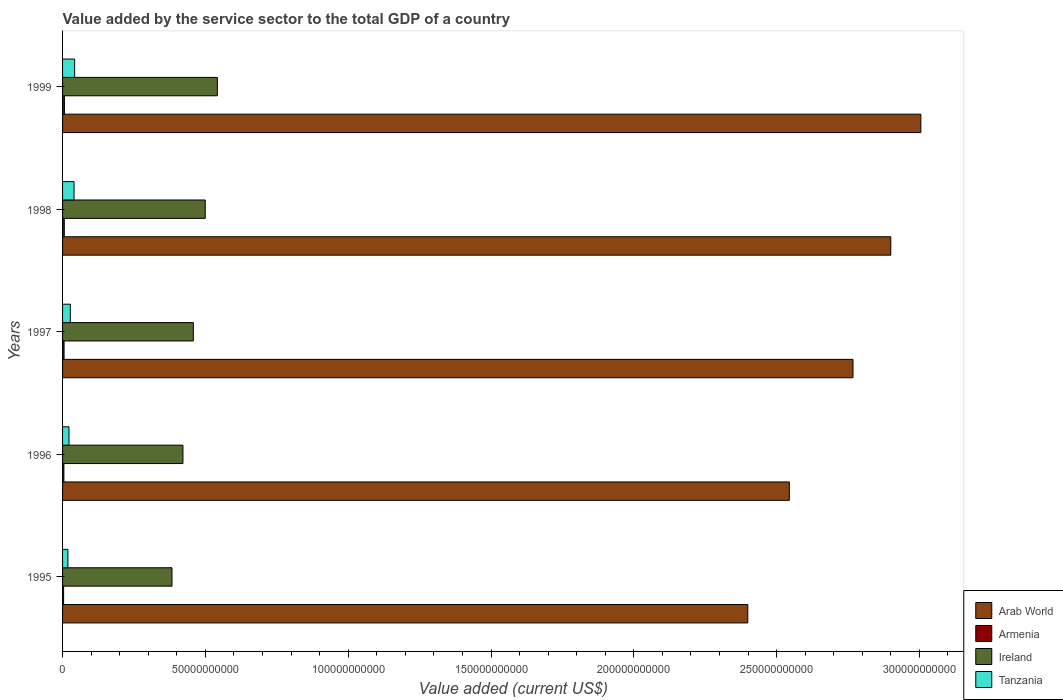Are the number of bars per tick equal to the number of legend labels?
Offer a very short reply. Yes. In how many cases, is the number of bars for a given year not equal to the number of legend labels?
Ensure brevity in your answer.  0. What is the value added by the service sector to the total GDP in Ireland in 1998?
Your answer should be very brief. 5.00e+1. Across all years, what is the maximum value added by the service sector to the total GDP in Ireland?
Make the answer very short. 5.42e+1. Across all years, what is the minimum value added by the service sector to the total GDP in Tanzania?
Your answer should be very brief. 1.87e+09. What is the total value added by the service sector to the total GDP in Ireland in the graph?
Give a very brief answer. 2.30e+11. What is the difference between the value added by the service sector to the total GDP in Tanzania in 1995 and that in 1996?
Offer a terse response. -3.81e+08. What is the difference between the value added by the service sector to the total GDP in Ireland in 1996 and the value added by the service sector to the total GDP in Arab World in 1995?
Provide a short and direct response. -1.98e+11. What is the average value added by the service sector to the total GDP in Armenia per year?
Give a very brief answer. 5.21e+08. In the year 1997, what is the difference between the value added by the service sector to the total GDP in Tanzania and value added by the service sector to the total GDP in Ireland?
Keep it short and to the point. -4.31e+1. In how many years, is the value added by the service sector to the total GDP in Ireland greater than 80000000000 US$?
Provide a short and direct response. 0. What is the ratio of the value added by the service sector to the total GDP in Ireland in 1996 to that in 1998?
Your response must be concise. 0.84. What is the difference between the highest and the second highest value added by the service sector to the total GDP in Ireland?
Give a very brief answer. 4.24e+09. What is the difference between the highest and the lowest value added by the service sector to the total GDP in Armenia?
Keep it short and to the point. 2.83e+08. In how many years, is the value added by the service sector to the total GDP in Arab World greater than the average value added by the service sector to the total GDP in Arab World taken over all years?
Your answer should be compact. 3. Is the sum of the value added by the service sector to the total GDP in Arab World in 1996 and 1998 greater than the maximum value added by the service sector to the total GDP in Armenia across all years?
Provide a short and direct response. Yes. Is it the case that in every year, the sum of the value added by the service sector to the total GDP in Arab World and value added by the service sector to the total GDP in Ireland is greater than the sum of value added by the service sector to the total GDP in Armenia and value added by the service sector to the total GDP in Tanzania?
Your response must be concise. Yes. What does the 3rd bar from the top in 1997 represents?
Provide a succinct answer. Armenia. What does the 2nd bar from the bottom in 1999 represents?
Offer a terse response. Armenia. How many bars are there?
Keep it short and to the point. 20. How many years are there in the graph?
Provide a short and direct response. 5. How are the legend labels stacked?
Make the answer very short. Vertical. What is the title of the graph?
Provide a succinct answer. Value added by the service sector to the total GDP of a country. Does "Ethiopia" appear as one of the legend labels in the graph?
Offer a very short reply. No. What is the label or title of the X-axis?
Ensure brevity in your answer.  Value added (current US$). What is the Value added (current US$) in Arab World in 1995?
Keep it short and to the point. 2.40e+11. What is the Value added (current US$) of Armenia in 1995?
Give a very brief answer. 3.64e+08. What is the Value added (current US$) in Ireland in 1995?
Keep it short and to the point. 3.83e+1. What is the Value added (current US$) of Tanzania in 1995?
Offer a terse response. 1.87e+09. What is the Value added (current US$) in Arab World in 1996?
Your answer should be very brief. 2.54e+11. What is the Value added (current US$) in Armenia in 1996?
Offer a terse response. 4.62e+08. What is the Value added (current US$) of Ireland in 1996?
Ensure brevity in your answer.  4.21e+1. What is the Value added (current US$) of Tanzania in 1996?
Your answer should be very brief. 2.25e+09. What is the Value added (current US$) in Arab World in 1997?
Offer a very short reply. 2.77e+11. What is the Value added (current US$) of Armenia in 1997?
Your response must be concise. 5.25e+08. What is the Value added (current US$) of Ireland in 1997?
Your response must be concise. 4.58e+1. What is the Value added (current US$) in Tanzania in 1997?
Ensure brevity in your answer.  2.72e+09. What is the Value added (current US$) in Arab World in 1998?
Provide a short and direct response. 2.90e+11. What is the Value added (current US$) of Armenia in 1998?
Your answer should be very brief. 6.06e+08. What is the Value added (current US$) of Ireland in 1998?
Your answer should be compact. 5.00e+1. What is the Value added (current US$) in Tanzania in 1998?
Ensure brevity in your answer.  4.02e+09. What is the Value added (current US$) of Arab World in 1999?
Your response must be concise. 3.00e+11. What is the Value added (current US$) in Armenia in 1999?
Make the answer very short. 6.47e+08. What is the Value added (current US$) in Ireland in 1999?
Make the answer very short. 5.42e+1. What is the Value added (current US$) in Tanzania in 1999?
Your response must be concise. 4.23e+09. Across all years, what is the maximum Value added (current US$) of Arab World?
Offer a very short reply. 3.00e+11. Across all years, what is the maximum Value added (current US$) of Armenia?
Offer a terse response. 6.47e+08. Across all years, what is the maximum Value added (current US$) of Ireland?
Your response must be concise. 5.42e+1. Across all years, what is the maximum Value added (current US$) in Tanzania?
Ensure brevity in your answer.  4.23e+09. Across all years, what is the minimum Value added (current US$) of Arab World?
Keep it short and to the point. 2.40e+11. Across all years, what is the minimum Value added (current US$) of Armenia?
Ensure brevity in your answer.  3.64e+08. Across all years, what is the minimum Value added (current US$) of Ireland?
Provide a short and direct response. 3.83e+1. Across all years, what is the minimum Value added (current US$) of Tanzania?
Give a very brief answer. 1.87e+09. What is the total Value added (current US$) of Arab World in the graph?
Your response must be concise. 1.36e+12. What is the total Value added (current US$) in Armenia in the graph?
Provide a short and direct response. 2.60e+09. What is the total Value added (current US$) of Ireland in the graph?
Provide a short and direct response. 2.30e+11. What is the total Value added (current US$) of Tanzania in the graph?
Your response must be concise. 1.51e+1. What is the difference between the Value added (current US$) of Arab World in 1995 and that in 1996?
Ensure brevity in your answer.  -1.46e+1. What is the difference between the Value added (current US$) of Armenia in 1995 and that in 1996?
Make the answer very short. -9.73e+07. What is the difference between the Value added (current US$) of Ireland in 1995 and that in 1996?
Offer a terse response. -3.84e+09. What is the difference between the Value added (current US$) of Tanzania in 1995 and that in 1996?
Offer a terse response. -3.81e+08. What is the difference between the Value added (current US$) in Arab World in 1995 and that in 1997?
Provide a short and direct response. -3.68e+1. What is the difference between the Value added (current US$) of Armenia in 1995 and that in 1997?
Provide a short and direct response. -1.61e+08. What is the difference between the Value added (current US$) of Ireland in 1995 and that in 1997?
Keep it short and to the point. -7.48e+09. What is the difference between the Value added (current US$) in Tanzania in 1995 and that in 1997?
Give a very brief answer. -8.56e+08. What is the difference between the Value added (current US$) in Arab World in 1995 and that in 1998?
Provide a succinct answer. -5.01e+1. What is the difference between the Value added (current US$) of Armenia in 1995 and that in 1998?
Offer a very short reply. -2.41e+08. What is the difference between the Value added (current US$) in Ireland in 1995 and that in 1998?
Your answer should be compact. -1.16e+1. What is the difference between the Value added (current US$) in Tanzania in 1995 and that in 1998?
Your answer should be very brief. -2.15e+09. What is the difference between the Value added (current US$) of Arab World in 1995 and that in 1999?
Provide a short and direct response. -6.06e+1. What is the difference between the Value added (current US$) of Armenia in 1995 and that in 1999?
Your response must be concise. -2.83e+08. What is the difference between the Value added (current US$) in Ireland in 1995 and that in 1999?
Make the answer very short. -1.59e+1. What is the difference between the Value added (current US$) of Tanzania in 1995 and that in 1999?
Give a very brief answer. -2.37e+09. What is the difference between the Value added (current US$) of Arab World in 1996 and that in 1997?
Your answer should be very brief. -2.23e+1. What is the difference between the Value added (current US$) of Armenia in 1996 and that in 1997?
Your answer should be very brief. -6.39e+07. What is the difference between the Value added (current US$) of Ireland in 1996 and that in 1997?
Your answer should be compact. -3.64e+09. What is the difference between the Value added (current US$) in Tanzania in 1996 and that in 1997?
Provide a succinct answer. -4.75e+08. What is the difference between the Value added (current US$) of Arab World in 1996 and that in 1998?
Ensure brevity in your answer.  -3.55e+1. What is the difference between the Value added (current US$) in Armenia in 1996 and that in 1998?
Make the answer very short. -1.44e+08. What is the difference between the Value added (current US$) of Ireland in 1996 and that in 1998?
Your answer should be compact. -7.81e+09. What is the difference between the Value added (current US$) of Tanzania in 1996 and that in 1998?
Ensure brevity in your answer.  -1.77e+09. What is the difference between the Value added (current US$) in Arab World in 1996 and that in 1999?
Keep it short and to the point. -4.60e+1. What is the difference between the Value added (current US$) of Armenia in 1996 and that in 1999?
Offer a terse response. -1.86e+08. What is the difference between the Value added (current US$) of Ireland in 1996 and that in 1999?
Provide a short and direct response. -1.20e+1. What is the difference between the Value added (current US$) of Tanzania in 1996 and that in 1999?
Your answer should be compact. -1.98e+09. What is the difference between the Value added (current US$) in Arab World in 1997 and that in 1998?
Make the answer very short. -1.32e+1. What is the difference between the Value added (current US$) of Armenia in 1997 and that in 1998?
Keep it short and to the point. -8.03e+07. What is the difference between the Value added (current US$) in Ireland in 1997 and that in 1998?
Your answer should be compact. -4.17e+09. What is the difference between the Value added (current US$) in Tanzania in 1997 and that in 1998?
Provide a short and direct response. -1.30e+09. What is the difference between the Value added (current US$) of Arab World in 1997 and that in 1999?
Offer a terse response. -2.38e+1. What is the difference between the Value added (current US$) in Armenia in 1997 and that in 1999?
Offer a terse response. -1.22e+08. What is the difference between the Value added (current US$) in Ireland in 1997 and that in 1999?
Ensure brevity in your answer.  -8.41e+09. What is the difference between the Value added (current US$) in Tanzania in 1997 and that in 1999?
Your answer should be compact. -1.51e+09. What is the difference between the Value added (current US$) in Arab World in 1998 and that in 1999?
Your response must be concise. -1.05e+1. What is the difference between the Value added (current US$) in Armenia in 1998 and that in 1999?
Your answer should be very brief. -4.17e+07. What is the difference between the Value added (current US$) in Ireland in 1998 and that in 1999?
Your answer should be compact. -4.24e+09. What is the difference between the Value added (current US$) of Tanzania in 1998 and that in 1999?
Offer a terse response. -2.11e+08. What is the difference between the Value added (current US$) in Arab World in 1995 and the Value added (current US$) in Armenia in 1996?
Provide a short and direct response. 2.39e+11. What is the difference between the Value added (current US$) in Arab World in 1995 and the Value added (current US$) in Ireland in 1996?
Keep it short and to the point. 1.98e+11. What is the difference between the Value added (current US$) of Arab World in 1995 and the Value added (current US$) of Tanzania in 1996?
Offer a very short reply. 2.38e+11. What is the difference between the Value added (current US$) in Armenia in 1995 and the Value added (current US$) in Ireland in 1996?
Keep it short and to the point. -4.18e+1. What is the difference between the Value added (current US$) in Armenia in 1995 and the Value added (current US$) in Tanzania in 1996?
Offer a terse response. -1.88e+09. What is the difference between the Value added (current US$) of Ireland in 1995 and the Value added (current US$) of Tanzania in 1996?
Provide a succinct answer. 3.61e+1. What is the difference between the Value added (current US$) of Arab World in 1995 and the Value added (current US$) of Armenia in 1997?
Provide a short and direct response. 2.39e+11. What is the difference between the Value added (current US$) of Arab World in 1995 and the Value added (current US$) of Ireland in 1997?
Give a very brief answer. 1.94e+11. What is the difference between the Value added (current US$) in Arab World in 1995 and the Value added (current US$) in Tanzania in 1997?
Your answer should be compact. 2.37e+11. What is the difference between the Value added (current US$) of Armenia in 1995 and the Value added (current US$) of Ireland in 1997?
Give a very brief answer. -4.54e+1. What is the difference between the Value added (current US$) of Armenia in 1995 and the Value added (current US$) of Tanzania in 1997?
Provide a succinct answer. -2.36e+09. What is the difference between the Value added (current US$) in Ireland in 1995 and the Value added (current US$) in Tanzania in 1997?
Your answer should be very brief. 3.56e+1. What is the difference between the Value added (current US$) in Arab World in 1995 and the Value added (current US$) in Armenia in 1998?
Give a very brief answer. 2.39e+11. What is the difference between the Value added (current US$) of Arab World in 1995 and the Value added (current US$) of Ireland in 1998?
Offer a very short reply. 1.90e+11. What is the difference between the Value added (current US$) of Arab World in 1995 and the Value added (current US$) of Tanzania in 1998?
Make the answer very short. 2.36e+11. What is the difference between the Value added (current US$) of Armenia in 1995 and the Value added (current US$) of Ireland in 1998?
Your response must be concise. -4.96e+1. What is the difference between the Value added (current US$) of Armenia in 1995 and the Value added (current US$) of Tanzania in 1998?
Your answer should be compact. -3.66e+09. What is the difference between the Value added (current US$) in Ireland in 1995 and the Value added (current US$) in Tanzania in 1998?
Keep it short and to the point. 3.43e+1. What is the difference between the Value added (current US$) of Arab World in 1995 and the Value added (current US$) of Armenia in 1999?
Provide a short and direct response. 2.39e+11. What is the difference between the Value added (current US$) of Arab World in 1995 and the Value added (current US$) of Ireland in 1999?
Ensure brevity in your answer.  1.86e+11. What is the difference between the Value added (current US$) of Arab World in 1995 and the Value added (current US$) of Tanzania in 1999?
Your response must be concise. 2.36e+11. What is the difference between the Value added (current US$) of Armenia in 1995 and the Value added (current US$) of Ireland in 1999?
Your response must be concise. -5.38e+1. What is the difference between the Value added (current US$) in Armenia in 1995 and the Value added (current US$) in Tanzania in 1999?
Your answer should be compact. -3.87e+09. What is the difference between the Value added (current US$) in Ireland in 1995 and the Value added (current US$) in Tanzania in 1999?
Your answer should be compact. 3.41e+1. What is the difference between the Value added (current US$) of Arab World in 1996 and the Value added (current US$) of Armenia in 1997?
Ensure brevity in your answer.  2.54e+11. What is the difference between the Value added (current US$) in Arab World in 1996 and the Value added (current US$) in Ireland in 1997?
Your answer should be very brief. 2.09e+11. What is the difference between the Value added (current US$) of Arab World in 1996 and the Value added (current US$) of Tanzania in 1997?
Your answer should be very brief. 2.52e+11. What is the difference between the Value added (current US$) of Armenia in 1996 and the Value added (current US$) of Ireland in 1997?
Keep it short and to the point. -4.53e+1. What is the difference between the Value added (current US$) of Armenia in 1996 and the Value added (current US$) of Tanzania in 1997?
Ensure brevity in your answer.  -2.26e+09. What is the difference between the Value added (current US$) of Ireland in 1996 and the Value added (current US$) of Tanzania in 1997?
Make the answer very short. 3.94e+1. What is the difference between the Value added (current US$) of Arab World in 1996 and the Value added (current US$) of Armenia in 1998?
Give a very brief answer. 2.54e+11. What is the difference between the Value added (current US$) of Arab World in 1996 and the Value added (current US$) of Ireland in 1998?
Keep it short and to the point. 2.04e+11. What is the difference between the Value added (current US$) of Arab World in 1996 and the Value added (current US$) of Tanzania in 1998?
Offer a terse response. 2.50e+11. What is the difference between the Value added (current US$) in Armenia in 1996 and the Value added (current US$) in Ireland in 1998?
Offer a very short reply. -4.95e+1. What is the difference between the Value added (current US$) in Armenia in 1996 and the Value added (current US$) in Tanzania in 1998?
Provide a short and direct response. -3.56e+09. What is the difference between the Value added (current US$) of Ireland in 1996 and the Value added (current US$) of Tanzania in 1998?
Your answer should be compact. 3.81e+1. What is the difference between the Value added (current US$) of Arab World in 1996 and the Value added (current US$) of Armenia in 1999?
Provide a short and direct response. 2.54e+11. What is the difference between the Value added (current US$) in Arab World in 1996 and the Value added (current US$) in Ireland in 1999?
Ensure brevity in your answer.  2.00e+11. What is the difference between the Value added (current US$) in Arab World in 1996 and the Value added (current US$) in Tanzania in 1999?
Provide a succinct answer. 2.50e+11. What is the difference between the Value added (current US$) of Armenia in 1996 and the Value added (current US$) of Ireland in 1999?
Offer a very short reply. -5.37e+1. What is the difference between the Value added (current US$) in Armenia in 1996 and the Value added (current US$) in Tanzania in 1999?
Give a very brief answer. -3.77e+09. What is the difference between the Value added (current US$) in Ireland in 1996 and the Value added (current US$) in Tanzania in 1999?
Provide a succinct answer. 3.79e+1. What is the difference between the Value added (current US$) in Arab World in 1997 and the Value added (current US$) in Armenia in 1998?
Your answer should be compact. 2.76e+11. What is the difference between the Value added (current US$) in Arab World in 1997 and the Value added (current US$) in Ireland in 1998?
Provide a short and direct response. 2.27e+11. What is the difference between the Value added (current US$) in Arab World in 1997 and the Value added (current US$) in Tanzania in 1998?
Ensure brevity in your answer.  2.73e+11. What is the difference between the Value added (current US$) of Armenia in 1997 and the Value added (current US$) of Ireland in 1998?
Offer a terse response. -4.94e+1. What is the difference between the Value added (current US$) of Armenia in 1997 and the Value added (current US$) of Tanzania in 1998?
Provide a succinct answer. -3.50e+09. What is the difference between the Value added (current US$) of Ireland in 1997 and the Value added (current US$) of Tanzania in 1998?
Offer a terse response. 4.18e+1. What is the difference between the Value added (current US$) of Arab World in 1997 and the Value added (current US$) of Armenia in 1999?
Your response must be concise. 2.76e+11. What is the difference between the Value added (current US$) in Arab World in 1997 and the Value added (current US$) in Ireland in 1999?
Offer a very short reply. 2.23e+11. What is the difference between the Value added (current US$) of Arab World in 1997 and the Value added (current US$) of Tanzania in 1999?
Your answer should be very brief. 2.73e+11. What is the difference between the Value added (current US$) in Armenia in 1997 and the Value added (current US$) in Ireland in 1999?
Your response must be concise. -5.37e+1. What is the difference between the Value added (current US$) in Armenia in 1997 and the Value added (current US$) in Tanzania in 1999?
Your answer should be compact. -3.71e+09. What is the difference between the Value added (current US$) in Ireland in 1997 and the Value added (current US$) in Tanzania in 1999?
Offer a terse response. 4.16e+1. What is the difference between the Value added (current US$) in Arab World in 1998 and the Value added (current US$) in Armenia in 1999?
Make the answer very short. 2.89e+11. What is the difference between the Value added (current US$) in Arab World in 1998 and the Value added (current US$) in Ireland in 1999?
Your response must be concise. 2.36e+11. What is the difference between the Value added (current US$) in Arab World in 1998 and the Value added (current US$) in Tanzania in 1999?
Your response must be concise. 2.86e+11. What is the difference between the Value added (current US$) of Armenia in 1998 and the Value added (current US$) of Ireland in 1999?
Ensure brevity in your answer.  -5.36e+1. What is the difference between the Value added (current US$) in Armenia in 1998 and the Value added (current US$) in Tanzania in 1999?
Make the answer very short. -3.63e+09. What is the difference between the Value added (current US$) in Ireland in 1998 and the Value added (current US$) in Tanzania in 1999?
Your response must be concise. 4.57e+1. What is the average Value added (current US$) of Arab World per year?
Offer a terse response. 2.72e+11. What is the average Value added (current US$) in Armenia per year?
Keep it short and to the point. 5.21e+08. What is the average Value added (current US$) of Ireland per year?
Offer a very short reply. 4.61e+1. What is the average Value added (current US$) in Tanzania per year?
Your answer should be very brief. 3.02e+09. In the year 1995, what is the difference between the Value added (current US$) of Arab World and Value added (current US$) of Armenia?
Ensure brevity in your answer.  2.40e+11. In the year 1995, what is the difference between the Value added (current US$) of Arab World and Value added (current US$) of Ireland?
Make the answer very short. 2.02e+11. In the year 1995, what is the difference between the Value added (current US$) in Arab World and Value added (current US$) in Tanzania?
Ensure brevity in your answer.  2.38e+11. In the year 1995, what is the difference between the Value added (current US$) in Armenia and Value added (current US$) in Ireland?
Your response must be concise. -3.79e+1. In the year 1995, what is the difference between the Value added (current US$) of Armenia and Value added (current US$) of Tanzania?
Offer a very short reply. -1.50e+09. In the year 1995, what is the difference between the Value added (current US$) of Ireland and Value added (current US$) of Tanzania?
Keep it short and to the point. 3.64e+1. In the year 1996, what is the difference between the Value added (current US$) in Arab World and Value added (current US$) in Armenia?
Keep it short and to the point. 2.54e+11. In the year 1996, what is the difference between the Value added (current US$) in Arab World and Value added (current US$) in Ireland?
Offer a terse response. 2.12e+11. In the year 1996, what is the difference between the Value added (current US$) in Arab World and Value added (current US$) in Tanzania?
Your answer should be compact. 2.52e+11. In the year 1996, what is the difference between the Value added (current US$) of Armenia and Value added (current US$) of Ireland?
Provide a short and direct response. -4.17e+1. In the year 1996, what is the difference between the Value added (current US$) of Armenia and Value added (current US$) of Tanzania?
Make the answer very short. -1.79e+09. In the year 1996, what is the difference between the Value added (current US$) in Ireland and Value added (current US$) in Tanzania?
Provide a short and direct response. 3.99e+1. In the year 1997, what is the difference between the Value added (current US$) of Arab World and Value added (current US$) of Armenia?
Provide a short and direct response. 2.76e+11. In the year 1997, what is the difference between the Value added (current US$) in Arab World and Value added (current US$) in Ireland?
Provide a succinct answer. 2.31e+11. In the year 1997, what is the difference between the Value added (current US$) in Arab World and Value added (current US$) in Tanzania?
Your answer should be compact. 2.74e+11. In the year 1997, what is the difference between the Value added (current US$) in Armenia and Value added (current US$) in Ireland?
Your response must be concise. -4.53e+1. In the year 1997, what is the difference between the Value added (current US$) of Armenia and Value added (current US$) of Tanzania?
Ensure brevity in your answer.  -2.20e+09. In the year 1997, what is the difference between the Value added (current US$) in Ireland and Value added (current US$) in Tanzania?
Offer a very short reply. 4.31e+1. In the year 1998, what is the difference between the Value added (current US$) in Arab World and Value added (current US$) in Armenia?
Keep it short and to the point. 2.89e+11. In the year 1998, what is the difference between the Value added (current US$) in Arab World and Value added (current US$) in Ireland?
Make the answer very short. 2.40e+11. In the year 1998, what is the difference between the Value added (current US$) in Arab World and Value added (current US$) in Tanzania?
Offer a very short reply. 2.86e+11. In the year 1998, what is the difference between the Value added (current US$) of Armenia and Value added (current US$) of Ireland?
Your answer should be very brief. -4.94e+1. In the year 1998, what is the difference between the Value added (current US$) of Armenia and Value added (current US$) of Tanzania?
Your answer should be compact. -3.42e+09. In the year 1998, what is the difference between the Value added (current US$) of Ireland and Value added (current US$) of Tanzania?
Keep it short and to the point. 4.59e+1. In the year 1999, what is the difference between the Value added (current US$) in Arab World and Value added (current US$) in Armenia?
Give a very brief answer. 3.00e+11. In the year 1999, what is the difference between the Value added (current US$) of Arab World and Value added (current US$) of Ireland?
Provide a succinct answer. 2.46e+11. In the year 1999, what is the difference between the Value added (current US$) of Arab World and Value added (current US$) of Tanzania?
Your answer should be very brief. 2.96e+11. In the year 1999, what is the difference between the Value added (current US$) of Armenia and Value added (current US$) of Ireland?
Give a very brief answer. -5.35e+1. In the year 1999, what is the difference between the Value added (current US$) of Armenia and Value added (current US$) of Tanzania?
Ensure brevity in your answer.  -3.58e+09. In the year 1999, what is the difference between the Value added (current US$) in Ireland and Value added (current US$) in Tanzania?
Your answer should be very brief. 5.00e+1. What is the ratio of the Value added (current US$) of Arab World in 1995 to that in 1996?
Provide a succinct answer. 0.94. What is the ratio of the Value added (current US$) in Armenia in 1995 to that in 1996?
Make the answer very short. 0.79. What is the ratio of the Value added (current US$) in Ireland in 1995 to that in 1996?
Your answer should be very brief. 0.91. What is the ratio of the Value added (current US$) of Tanzania in 1995 to that in 1996?
Your answer should be very brief. 0.83. What is the ratio of the Value added (current US$) in Arab World in 1995 to that in 1997?
Offer a very short reply. 0.87. What is the ratio of the Value added (current US$) of Armenia in 1995 to that in 1997?
Keep it short and to the point. 0.69. What is the ratio of the Value added (current US$) in Ireland in 1995 to that in 1997?
Give a very brief answer. 0.84. What is the ratio of the Value added (current US$) in Tanzania in 1995 to that in 1997?
Provide a short and direct response. 0.69. What is the ratio of the Value added (current US$) of Arab World in 1995 to that in 1998?
Your answer should be compact. 0.83. What is the ratio of the Value added (current US$) of Armenia in 1995 to that in 1998?
Your answer should be compact. 0.6. What is the ratio of the Value added (current US$) in Ireland in 1995 to that in 1998?
Provide a short and direct response. 0.77. What is the ratio of the Value added (current US$) in Tanzania in 1995 to that in 1998?
Offer a terse response. 0.46. What is the ratio of the Value added (current US$) of Arab World in 1995 to that in 1999?
Provide a succinct answer. 0.8. What is the ratio of the Value added (current US$) of Armenia in 1995 to that in 1999?
Your answer should be very brief. 0.56. What is the ratio of the Value added (current US$) in Ireland in 1995 to that in 1999?
Make the answer very short. 0.71. What is the ratio of the Value added (current US$) of Tanzania in 1995 to that in 1999?
Provide a succinct answer. 0.44. What is the ratio of the Value added (current US$) of Arab World in 1996 to that in 1997?
Ensure brevity in your answer.  0.92. What is the ratio of the Value added (current US$) of Armenia in 1996 to that in 1997?
Your response must be concise. 0.88. What is the ratio of the Value added (current US$) in Ireland in 1996 to that in 1997?
Give a very brief answer. 0.92. What is the ratio of the Value added (current US$) in Tanzania in 1996 to that in 1997?
Ensure brevity in your answer.  0.83. What is the ratio of the Value added (current US$) in Arab World in 1996 to that in 1998?
Give a very brief answer. 0.88. What is the ratio of the Value added (current US$) of Armenia in 1996 to that in 1998?
Provide a short and direct response. 0.76. What is the ratio of the Value added (current US$) in Ireland in 1996 to that in 1998?
Provide a succinct answer. 0.84. What is the ratio of the Value added (current US$) in Tanzania in 1996 to that in 1998?
Offer a terse response. 0.56. What is the ratio of the Value added (current US$) in Arab World in 1996 to that in 1999?
Ensure brevity in your answer.  0.85. What is the ratio of the Value added (current US$) of Armenia in 1996 to that in 1999?
Give a very brief answer. 0.71. What is the ratio of the Value added (current US$) of Ireland in 1996 to that in 1999?
Ensure brevity in your answer.  0.78. What is the ratio of the Value added (current US$) in Tanzania in 1996 to that in 1999?
Offer a very short reply. 0.53. What is the ratio of the Value added (current US$) of Arab World in 1997 to that in 1998?
Your response must be concise. 0.95. What is the ratio of the Value added (current US$) in Armenia in 1997 to that in 1998?
Give a very brief answer. 0.87. What is the ratio of the Value added (current US$) in Ireland in 1997 to that in 1998?
Ensure brevity in your answer.  0.92. What is the ratio of the Value added (current US$) in Tanzania in 1997 to that in 1998?
Give a very brief answer. 0.68. What is the ratio of the Value added (current US$) of Arab World in 1997 to that in 1999?
Provide a succinct answer. 0.92. What is the ratio of the Value added (current US$) in Armenia in 1997 to that in 1999?
Your response must be concise. 0.81. What is the ratio of the Value added (current US$) of Ireland in 1997 to that in 1999?
Your answer should be very brief. 0.84. What is the ratio of the Value added (current US$) in Tanzania in 1997 to that in 1999?
Provide a short and direct response. 0.64. What is the ratio of the Value added (current US$) of Arab World in 1998 to that in 1999?
Your answer should be compact. 0.96. What is the ratio of the Value added (current US$) of Armenia in 1998 to that in 1999?
Make the answer very short. 0.94. What is the ratio of the Value added (current US$) of Ireland in 1998 to that in 1999?
Provide a succinct answer. 0.92. What is the ratio of the Value added (current US$) of Tanzania in 1998 to that in 1999?
Give a very brief answer. 0.95. What is the difference between the highest and the second highest Value added (current US$) in Arab World?
Give a very brief answer. 1.05e+1. What is the difference between the highest and the second highest Value added (current US$) in Armenia?
Provide a succinct answer. 4.17e+07. What is the difference between the highest and the second highest Value added (current US$) of Ireland?
Keep it short and to the point. 4.24e+09. What is the difference between the highest and the second highest Value added (current US$) in Tanzania?
Make the answer very short. 2.11e+08. What is the difference between the highest and the lowest Value added (current US$) of Arab World?
Your response must be concise. 6.06e+1. What is the difference between the highest and the lowest Value added (current US$) of Armenia?
Your response must be concise. 2.83e+08. What is the difference between the highest and the lowest Value added (current US$) of Ireland?
Give a very brief answer. 1.59e+1. What is the difference between the highest and the lowest Value added (current US$) in Tanzania?
Offer a terse response. 2.37e+09. 